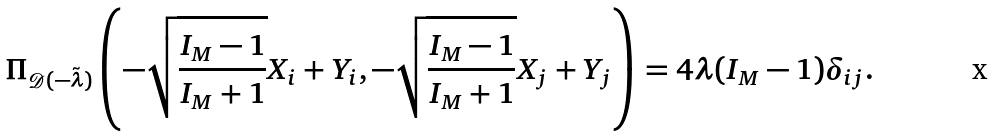<formula> <loc_0><loc_0><loc_500><loc_500>\Pi _ { { \mathcal { D } } ( - \tilde { \lambda } ) } \left ( - \sqrt { \frac { I _ { M } - 1 } { I _ { M } + 1 } } X _ { i } + Y _ { i } , - \sqrt { \frac { I _ { M } - 1 } { I _ { M } + 1 } } X _ { j } + Y _ { j } \right ) = 4 \lambda ( I _ { M } - 1 ) \delta _ { i j } .</formula> 